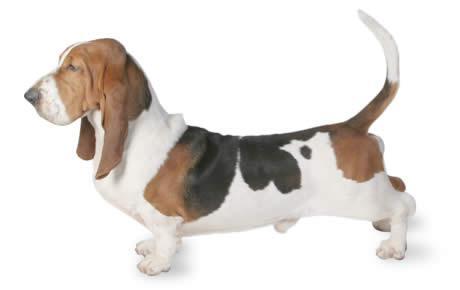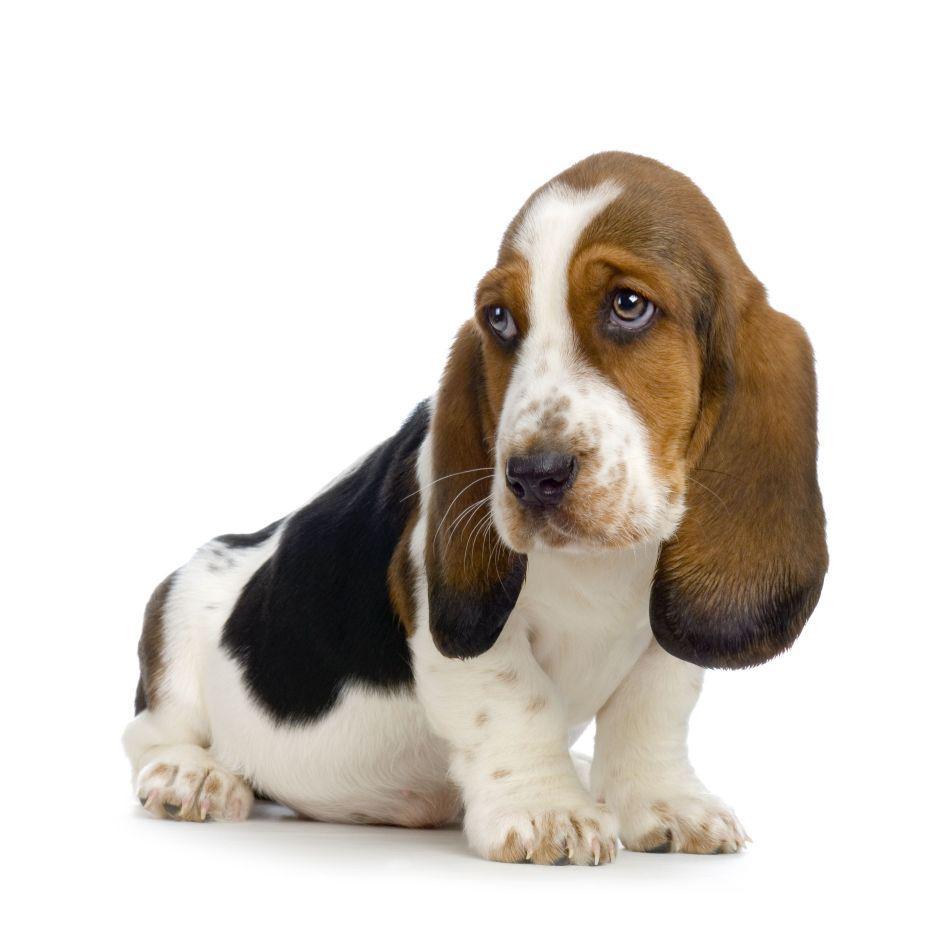The first image is the image on the left, the second image is the image on the right. Given the left and right images, does the statement "The dog in the image on the right is against a white background." hold true? Answer yes or no. Yes. 